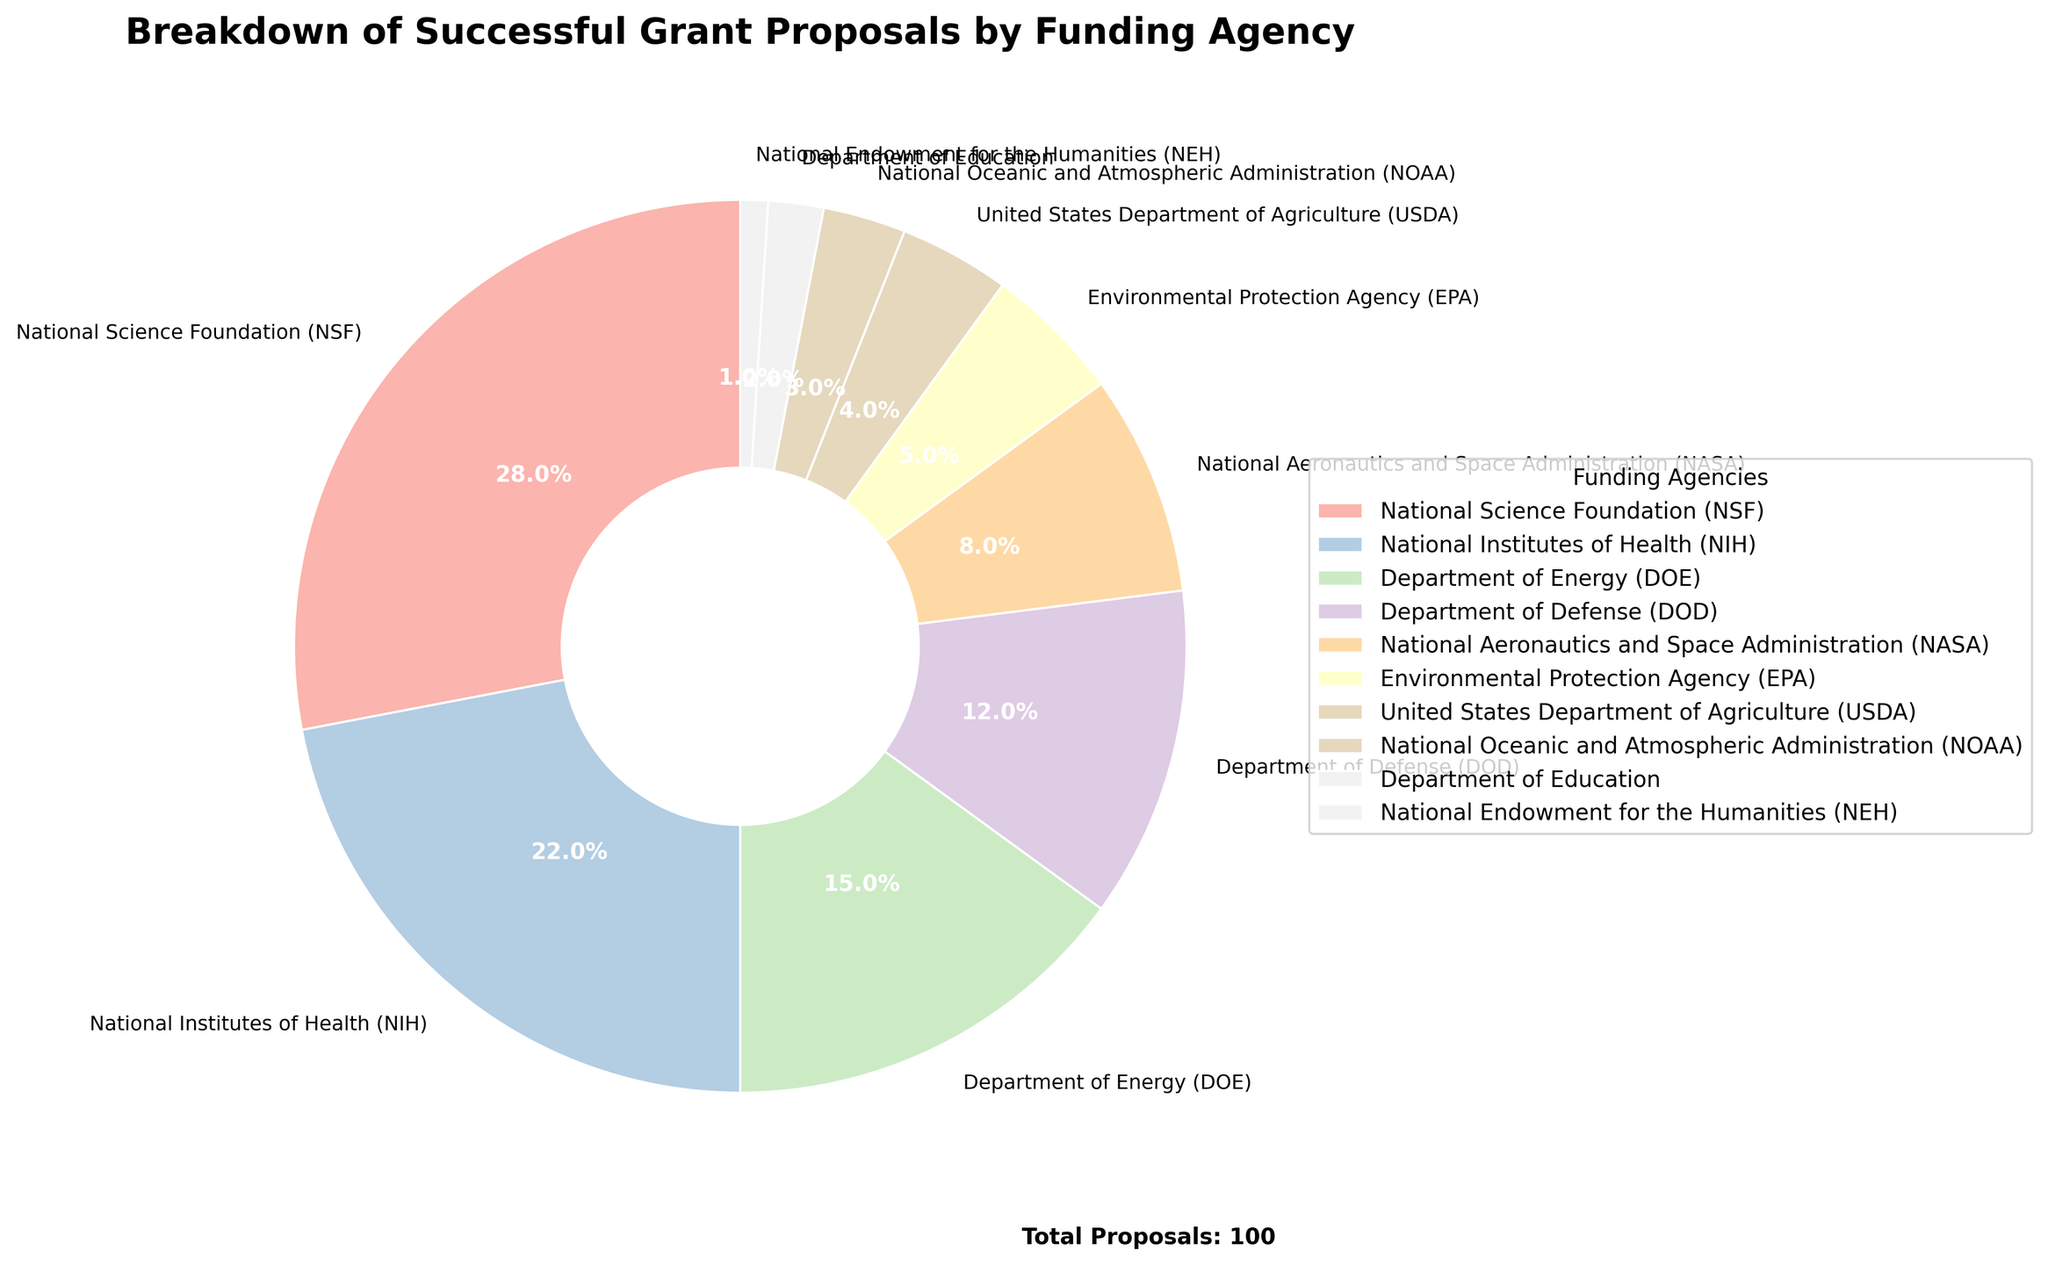What percentage of successful grant proposals are from the National Science Foundation (NSF)? Referring to the figure, the label corresponding to NSF shows it accounts for 28% of successful grant proposals.
Answer: 28% How does the percentage of successful proposals from the Department of Energy (DOE) compare with the National Institutes of Health (NIH)? From the figure, DOE has 15% and NIH has 22%. Comparing these two values, NIH has a higher percentage.
Answer: NIH has a higher percentage What is the combined percentage of successful proposals from the National Aeronautics and Space Administration (NASA) and the Environmental Protection Agency (EPA)? Adding the percentages shown in the figure for NASA (8%) and EPA (5%): 8% + 5% = 13%.
Answer: 13% Which funding agency has the least percentage of successful grant proposals? According to the figure, the National Endowment for the Humanities (NEH) has the smallest slice, showing 1%.
Answer: NEH What is the difference in the percentage of successful proposals between the Department of Defense (DOD) and the United States Department of Agriculture (USDA)? From the figure, DOD accounts for 12% and USDA for 4%. Subtract 4% from 12%: 12% - 4% = 8%.
Answer: 8% Identify the funding agencies whose combined successful proposal percentages equal to or exceed that of the National Science Foundation (NSF). NSF has 28%. Combining DOD (12%), NASA (8%), EPA (5%), USDA (4%), and NOAA (3%): 12% + 8% + 5% + 4% + 3% = 32%, which is more than 28%.
Answer: DOD, NASA, EPA, USDA, NOAA Compare the number of funding agencies with successful proposals less than 10% to those with 10% or more. According to the figure, agencies with less than 10% are NASA (8%), EPA (5%), USDA (4%), NOAA (3%), Department of Education (2%), and NEH (1%), total 6 agencies. Those with 10% or more are NSF (28%), NIH (22%), DOE (15%), and DOD (12%), total 4 agencies.
Answer: 6 agencies < 10% and 4 agencies >= 10% How much more percentage of successful proposals does NSF have compared to NASA? NSF has 28% and NASA has 8%. Subtract NASA's percentage from NSF's: 28% - 8% = 20%.
Answer: 20% What is the sum of the percentages for the top three funding agencies in terms of successful proposals? The top three funding agencies are NSF (28%), NIH (22%), and DOE (15%). Adding these: 28% + 22% + 15% = 65%.
Answer: 65% 